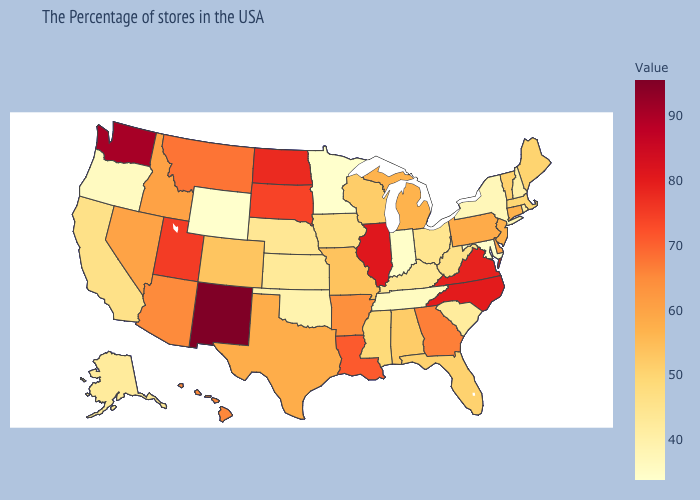Does South Dakota have a higher value than Missouri?
Concise answer only. Yes. Does Tennessee have a lower value than South Carolina?
Keep it brief. Yes. Among the states that border South Dakota , does North Dakota have the highest value?
Quick response, please. Yes. Which states hav the highest value in the MidWest?
Give a very brief answer. Illinois. Does Arkansas have a lower value than Utah?
Be succinct. Yes. Does Vermont have the lowest value in the USA?
Quick response, please. No. Which states have the highest value in the USA?
Short answer required. New Mexico. 